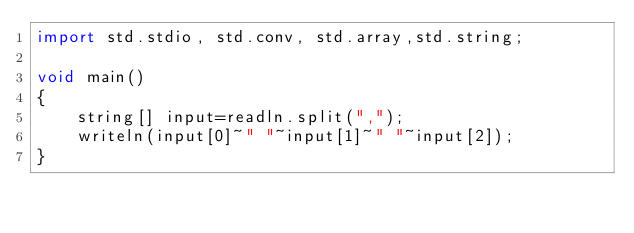<code> <loc_0><loc_0><loc_500><loc_500><_D_>import std.stdio, std.conv, std.array,std.string;

void main()
{
    string[] input=readln.split(",");
    writeln(input[0]~" "~input[1]~" "~input[2]);
}</code> 